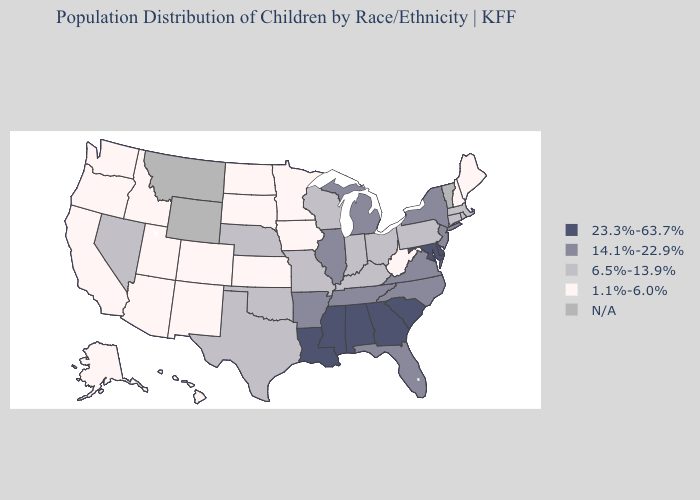What is the lowest value in the Northeast?
Concise answer only. 1.1%-6.0%. Name the states that have a value in the range N/A?
Quick response, please. Montana, Vermont, Wyoming. Which states hav the highest value in the South?
Quick response, please. Alabama, Delaware, Georgia, Louisiana, Maryland, Mississippi, South Carolina. What is the highest value in the USA?
Short answer required. 23.3%-63.7%. What is the value of New Mexico?
Give a very brief answer. 1.1%-6.0%. Name the states that have a value in the range 23.3%-63.7%?
Quick response, please. Alabama, Delaware, Georgia, Louisiana, Maryland, Mississippi, South Carolina. Which states have the lowest value in the West?
Give a very brief answer. Alaska, Arizona, California, Colorado, Hawaii, Idaho, New Mexico, Oregon, Utah, Washington. Name the states that have a value in the range 23.3%-63.7%?
Give a very brief answer. Alabama, Delaware, Georgia, Louisiana, Maryland, Mississippi, South Carolina. Which states hav the highest value in the Northeast?
Short answer required. New Jersey, New York. Which states hav the highest value in the South?
Keep it brief. Alabama, Delaware, Georgia, Louisiana, Maryland, Mississippi, South Carolina. Name the states that have a value in the range 14.1%-22.9%?
Concise answer only. Arkansas, Florida, Illinois, Michigan, New Jersey, New York, North Carolina, Tennessee, Virginia. What is the value of New Jersey?
Quick response, please. 14.1%-22.9%. Among the states that border Ohio , which have the lowest value?
Be succinct. West Virginia. Name the states that have a value in the range 14.1%-22.9%?
Give a very brief answer. Arkansas, Florida, Illinois, Michigan, New Jersey, New York, North Carolina, Tennessee, Virginia. What is the lowest value in states that border New Mexico?
Write a very short answer. 1.1%-6.0%. 